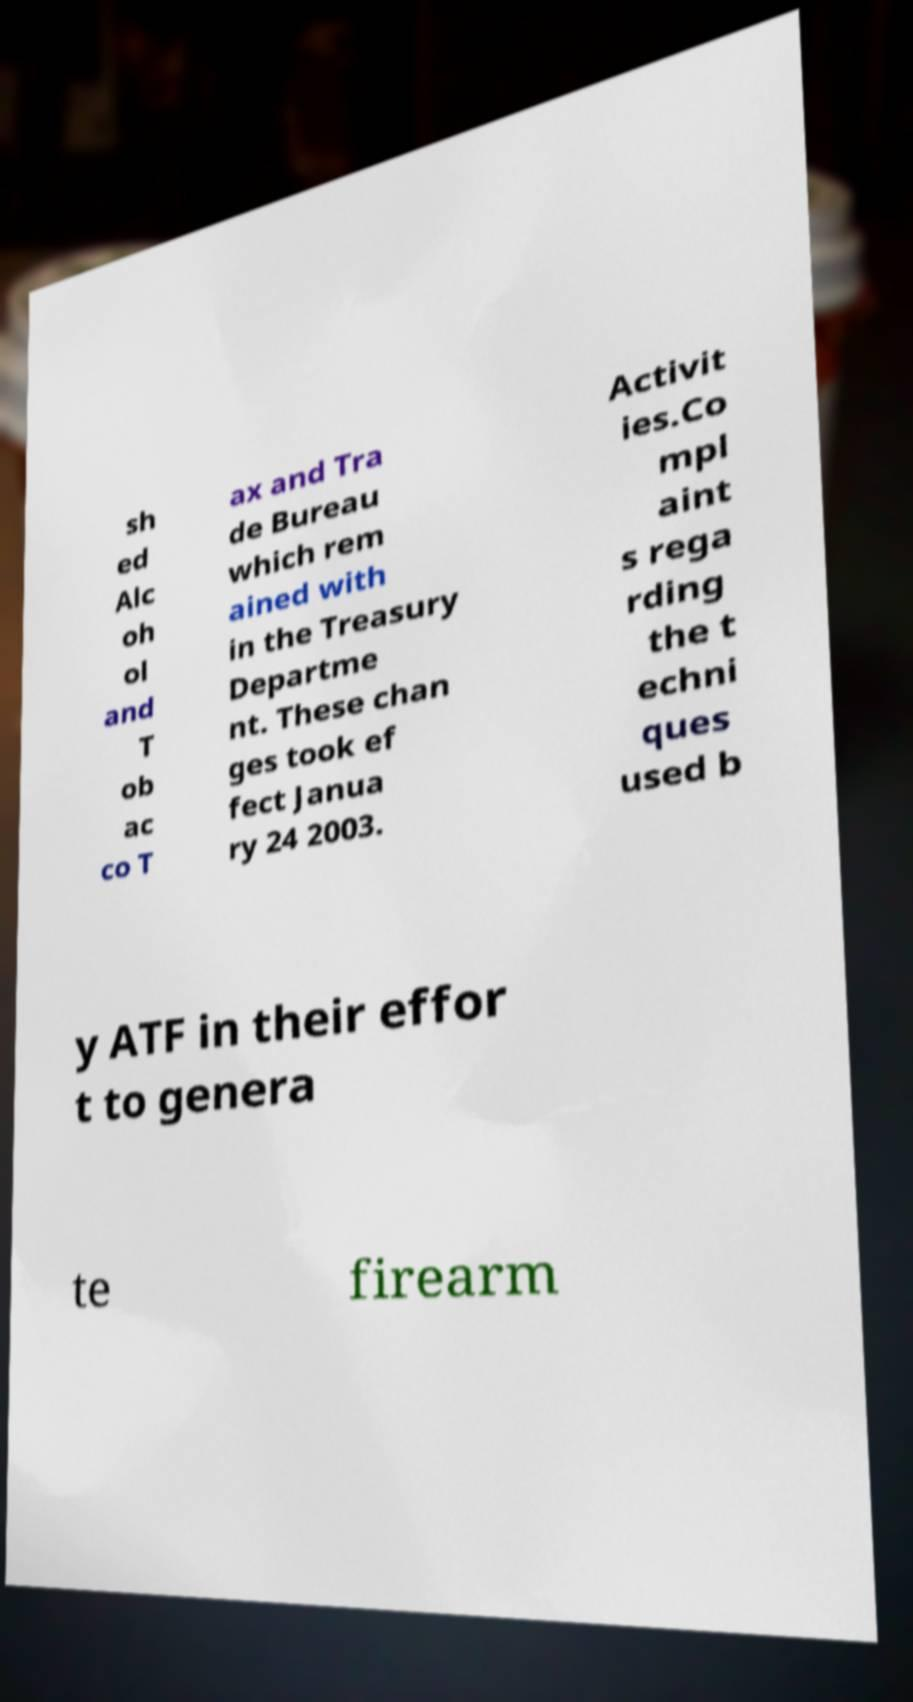Please read and relay the text visible in this image. What does it say? sh ed Alc oh ol and T ob ac co T ax and Tra de Bureau which rem ained with in the Treasury Departme nt. These chan ges took ef fect Janua ry 24 2003. Activit ies.Co mpl aint s rega rding the t echni ques used b y ATF in their effor t to genera te firearm 